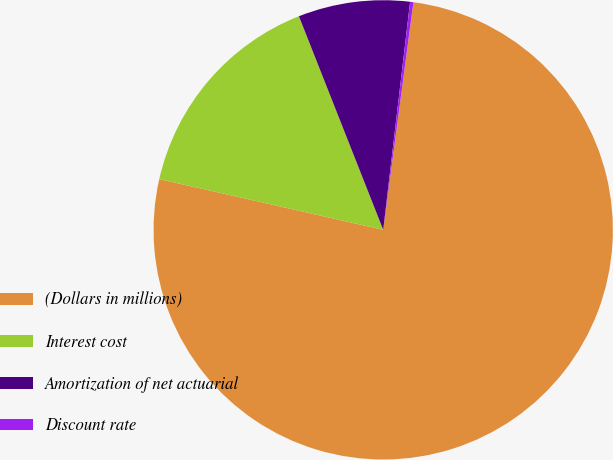<chart> <loc_0><loc_0><loc_500><loc_500><pie_chart><fcel>(Dollars in millions)<fcel>Interest cost<fcel>Amortization of net actuarial<fcel>Discount rate<nl><fcel>76.45%<fcel>15.47%<fcel>7.85%<fcel>0.23%<nl></chart> 